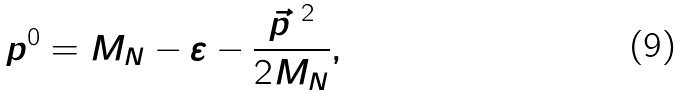Convert formula to latex. <formula><loc_0><loc_0><loc_500><loc_500>p ^ { 0 } = M _ { N } - \varepsilon - \frac { \vec { p } ^ { \ 2 } } { 2 M _ { N } } ,</formula> 